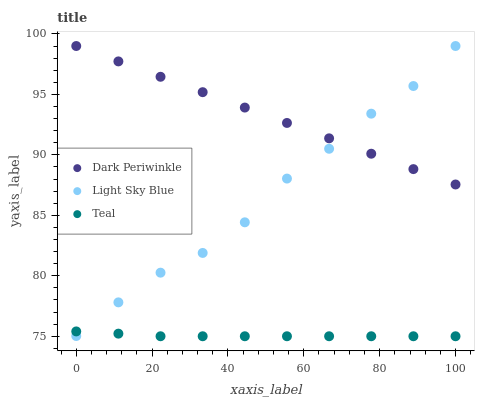Does Teal have the minimum area under the curve?
Answer yes or no. Yes. Does Dark Periwinkle have the maximum area under the curve?
Answer yes or no. Yes. Does Dark Periwinkle have the minimum area under the curve?
Answer yes or no. No. Does Teal have the maximum area under the curve?
Answer yes or no. No. Is Dark Periwinkle the smoothest?
Answer yes or no. Yes. Is Light Sky Blue the roughest?
Answer yes or no. Yes. Is Teal the smoothest?
Answer yes or no. No. Is Teal the roughest?
Answer yes or no. No. Does Teal have the lowest value?
Answer yes or no. Yes. Does Dark Periwinkle have the lowest value?
Answer yes or no. No. Does Dark Periwinkle have the highest value?
Answer yes or no. Yes. Does Teal have the highest value?
Answer yes or no. No. Is Teal less than Dark Periwinkle?
Answer yes or no. Yes. Is Dark Periwinkle greater than Teal?
Answer yes or no. Yes. Does Light Sky Blue intersect Teal?
Answer yes or no. Yes. Is Light Sky Blue less than Teal?
Answer yes or no. No. Is Light Sky Blue greater than Teal?
Answer yes or no. No. Does Teal intersect Dark Periwinkle?
Answer yes or no. No. 